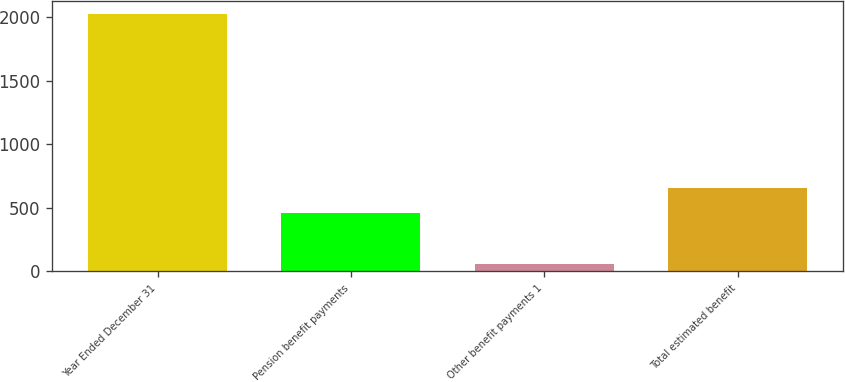<chart> <loc_0><loc_0><loc_500><loc_500><bar_chart><fcel>Year Ended December 31<fcel>Pension benefit payments<fcel>Other benefit payments 1<fcel>Total estimated benefit<nl><fcel>2021<fcel>460<fcel>59<fcel>656.2<nl></chart> 